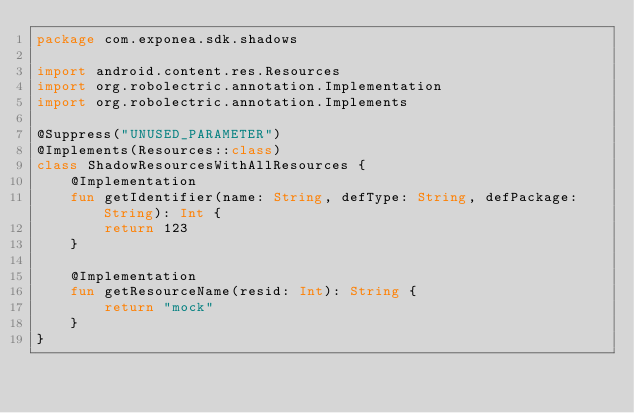Convert code to text. <code><loc_0><loc_0><loc_500><loc_500><_Kotlin_>package com.exponea.sdk.shadows

import android.content.res.Resources
import org.robolectric.annotation.Implementation
import org.robolectric.annotation.Implements

@Suppress("UNUSED_PARAMETER")
@Implements(Resources::class)
class ShadowResourcesWithAllResources {
    @Implementation
    fun getIdentifier(name: String, defType: String, defPackage: String): Int {
        return 123
    }

    @Implementation
    fun getResourceName(resid: Int): String {
        return "mock"
    }
}
</code> 